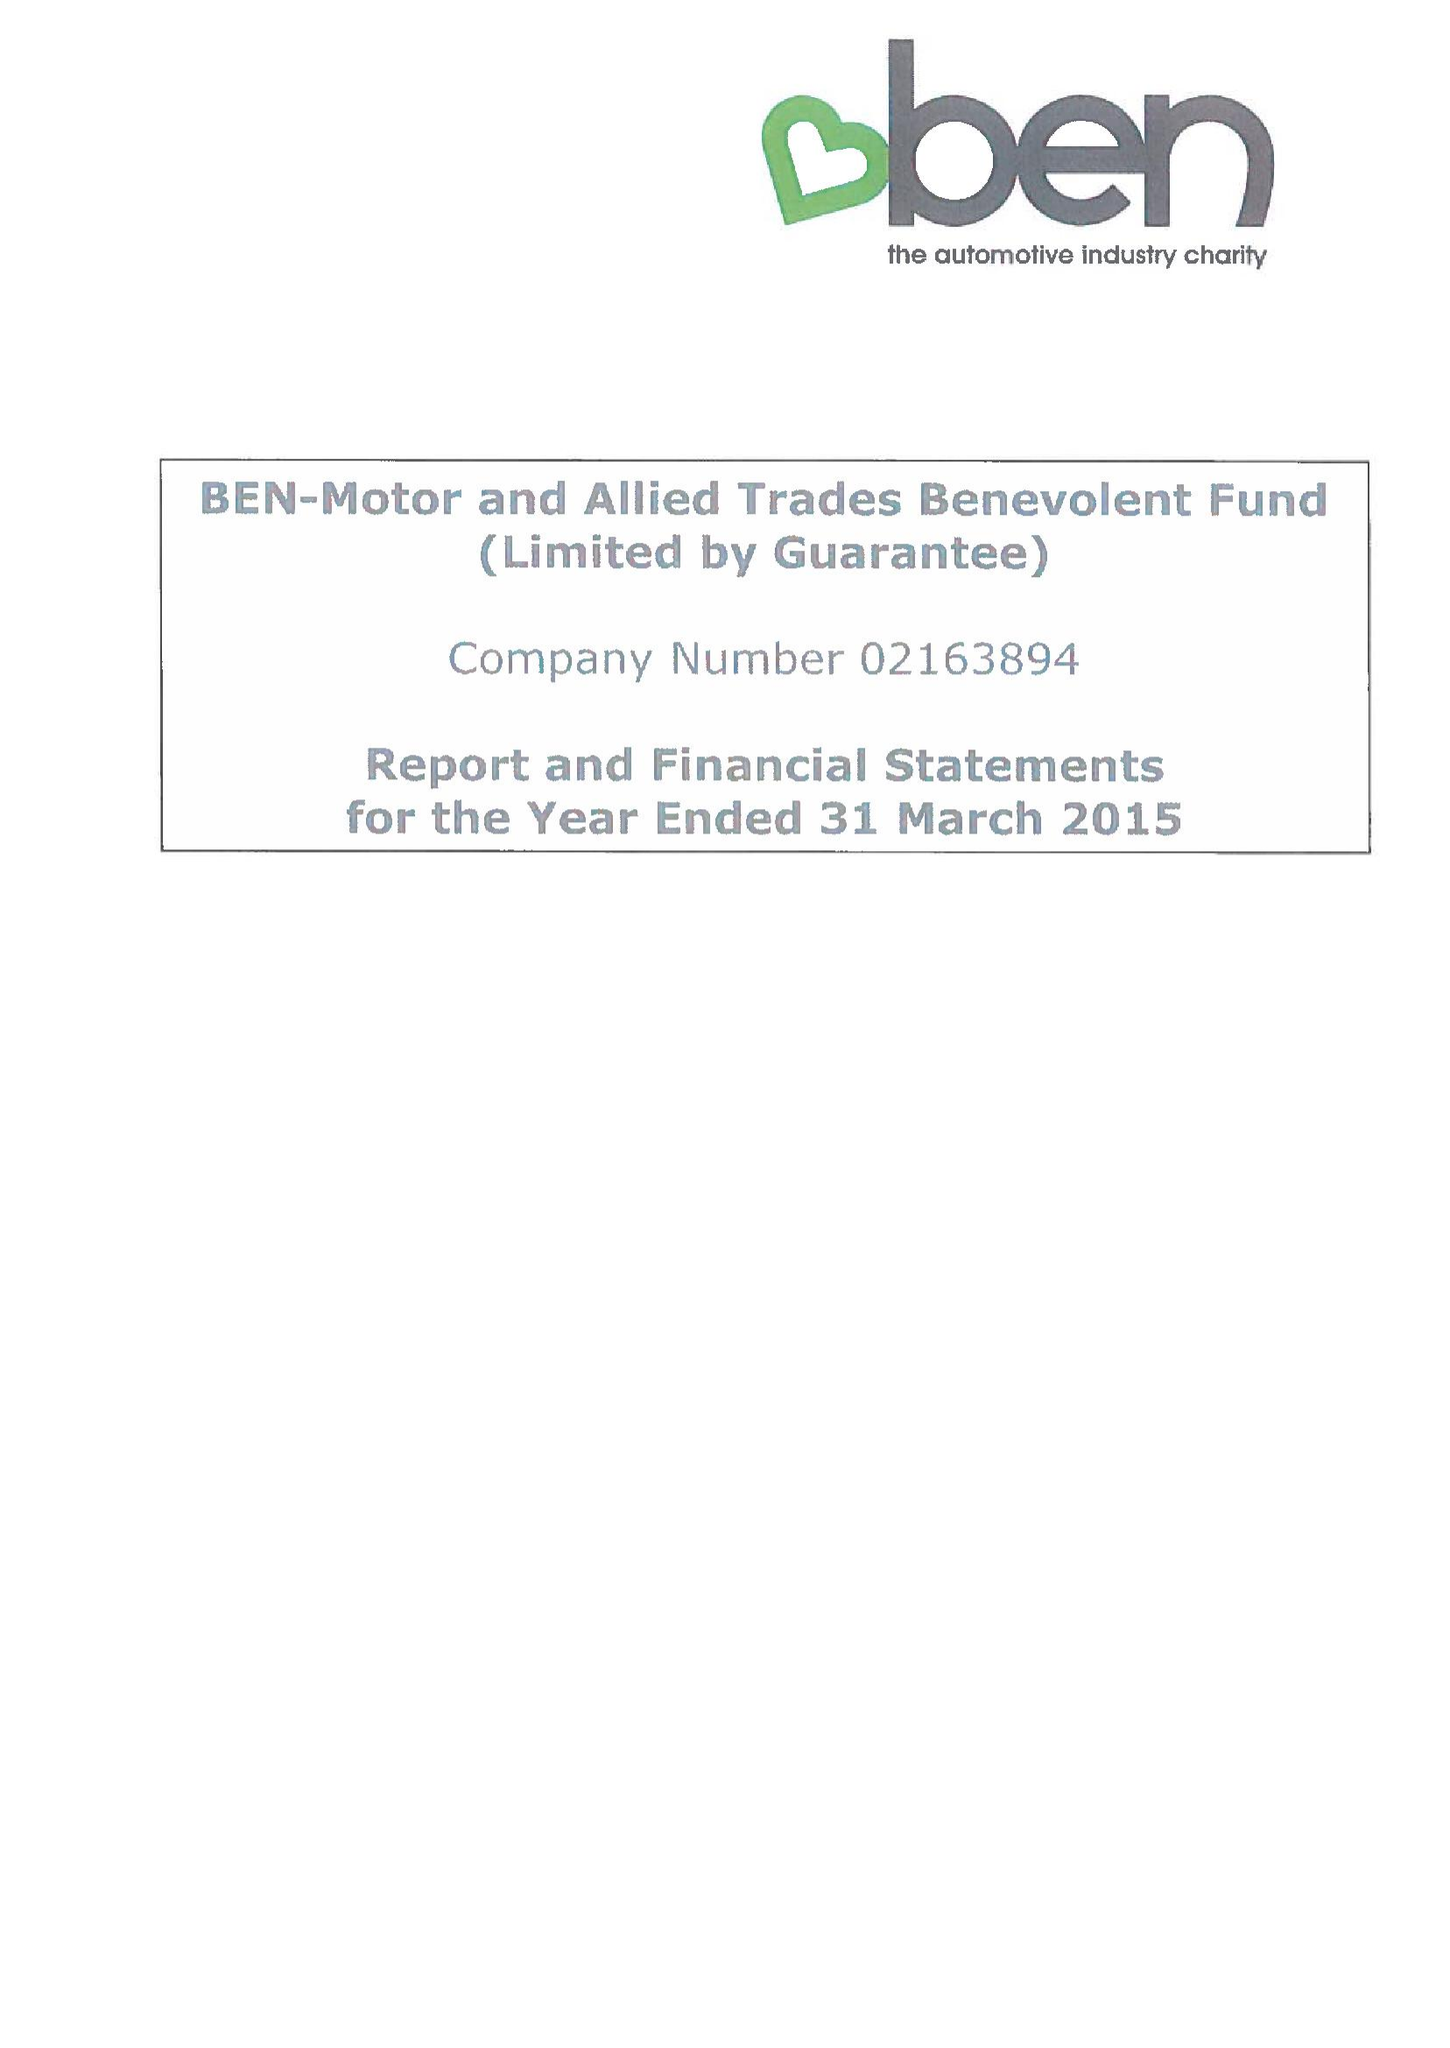What is the value for the address__street_line?
Answer the question using a single word or phrase. RISE ROAD 